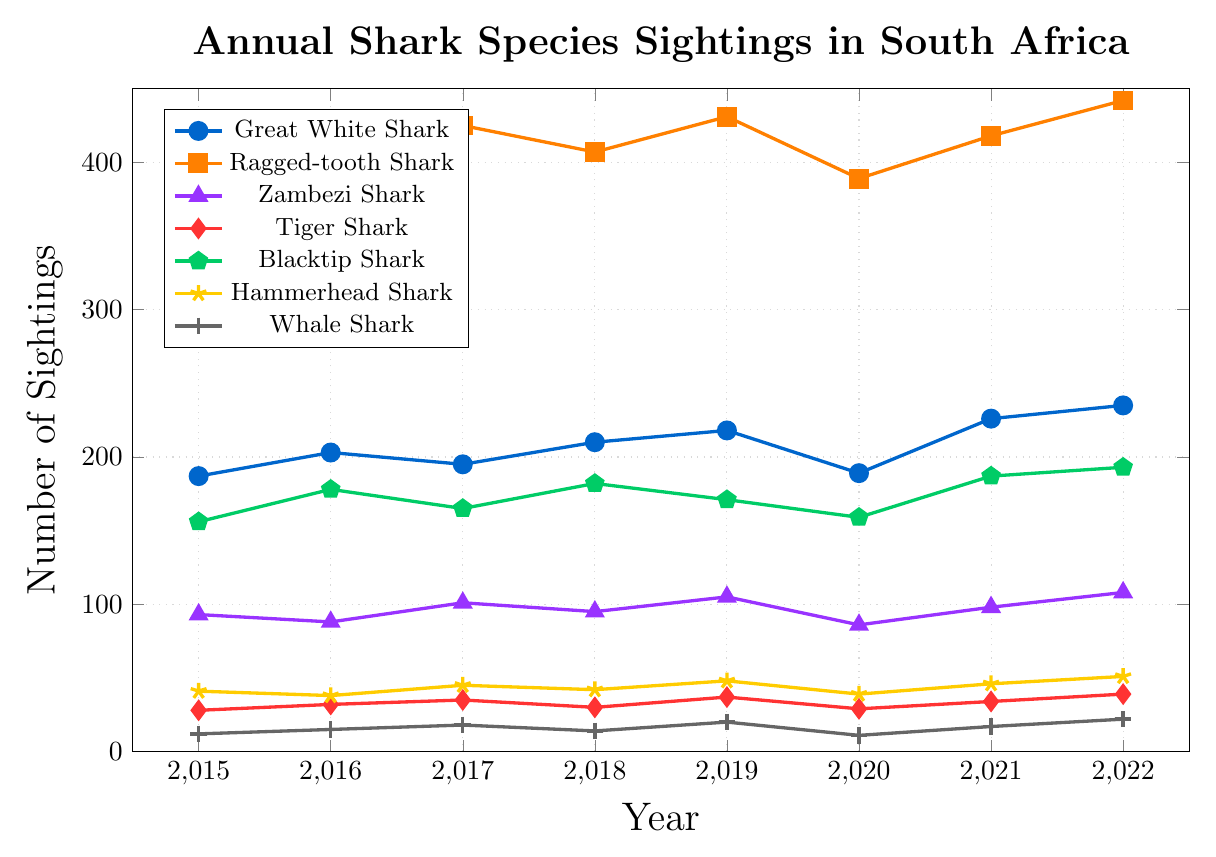What is the overall trend in the sightings of Great White Sharks from 2015 to 2022? To identify the trend, we look at the data points for Great White Shark sightings from 2015 to 2022. Sightings increased from 187 in 2015 to 235 in 2022 with some fluctuations along the way.
Answer: Increasing trend Which shark species had the highest number of sightings in 2022? To find the species with the highest sightings in 2022, compare the sightings numbers for all shark species in 2022. Ragged-tooth Shark had the highest sightings with 442.
Answer: Ragged-tooth Shark What is the average number of Hammerhead Shark sightings from 2015 to 2022? To calculate this, sum the numbers: (41 + 38 + 45 + 42 + 48 + 39 + 46 + 51) = 350, and then divide by the number of years: 350 / 8 = 43.75.
Answer: 43.75 Which year saw the lowest number of Whale Shark sightings? Comparing the numbers for Whale Shark sightings across all years, 2020 had the lowest number of sightings with 11.
Answer: 2020 Compare the sightings of Great White Sharks and Zambezi Sharks in 2020. How many more Great White Sharks were sighted? In 2020, there were 189 Great White Shark sightings and 86 Zambezi Shark sightings. The difference is 189 - 86.
Answer: 103 What is the total number of sightings for Blacktip Sharks over the years? Sum the annual sightings from 2015 to 2022 for Blacktip Sharks: 156 + 178 + 165 + 182 + 171 + 159 + 187 + 193 = 1391.
Answer: 1391 In which years did the sightings of Ragged-tooth Sharks decrease compared to the previous year? Compare sighting figures year by year. Sightings decreased from 2015 to 2016 (412 to 398) and from 2019 to 2020 (431 to 389).
Answer: 2016, 2020 What is the difference in the number of Tiger Shark sightings between 2018 and 2022? In 2018, there were 30 sightings and in 2022, there were 39 sightings. The difference is 39 - 30.
Answer: 9 How did the number of Whale Shark sightings change from 2016 to 2017? Compare the sightings in 2016 (15) and 2017 (18). The number of sightings increased by 18-15.
Answer: Increased by 3 